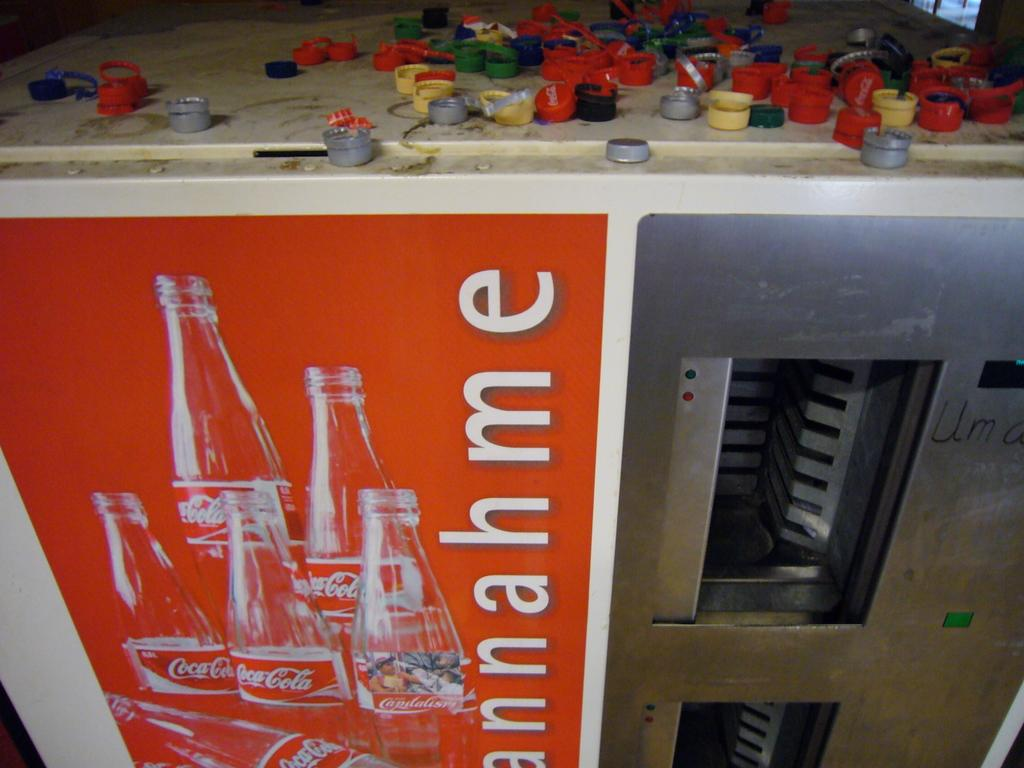Provide a one-sentence caption for the provided image. A coca cola vending machine has a large number of coloured bottle tops scattered on its top. 